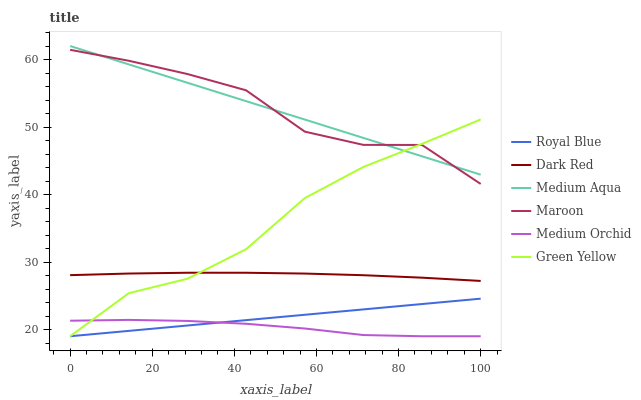Does Medium Orchid have the minimum area under the curve?
Answer yes or no. Yes. Does Maroon have the maximum area under the curve?
Answer yes or no. Yes. Does Maroon have the minimum area under the curve?
Answer yes or no. No. Does Medium Orchid have the maximum area under the curve?
Answer yes or no. No. Is Royal Blue the smoothest?
Answer yes or no. Yes. Is Maroon the roughest?
Answer yes or no. Yes. Is Medium Orchid the smoothest?
Answer yes or no. No. Is Medium Orchid the roughest?
Answer yes or no. No. Does Maroon have the lowest value?
Answer yes or no. No. Does Medium Aqua have the highest value?
Answer yes or no. Yes. Does Maroon have the highest value?
Answer yes or no. No. Is Dark Red less than Maroon?
Answer yes or no. Yes. Is Maroon greater than Royal Blue?
Answer yes or no. Yes. Does Medium Aqua intersect Maroon?
Answer yes or no. Yes. Is Medium Aqua less than Maroon?
Answer yes or no. No. Is Medium Aqua greater than Maroon?
Answer yes or no. No. Does Dark Red intersect Maroon?
Answer yes or no. No. 